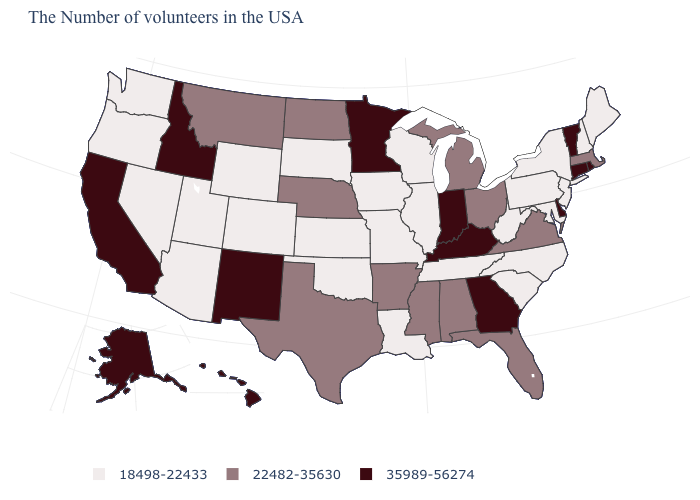Which states have the lowest value in the Northeast?
Answer briefly. Maine, New Hampshire, New York, New Jersey, Pennsylvania. Is the legend a continuous bar?
Keep it brief. No. Which states have the lowest value in the MidWest?
Concise answer only. Wisconsin, Illinois, Missouri, Iowa, Kansas, South Dakota. What is the value of Alabama?
Write a very short answer. 22482-35630. Name the states that have a value in the range 22482-35630?
Give a very brief answer. Massachusetts, Virginia, Ohio, Florida, Michigan, Alabama, Mississippi, Arkansas, Nebraska, Texas, North Dakota, Montana. What is the lowest value in states that border Iowa?
Keep it brief. 18498-22433. Name the states that have a value in the range 22482-35630?
Answer briefly. Massachusetts, Virginia, Ohio, Florida, Michigan, Alabama, Mississippi, Arkansas, Nebraska, Texas, North Dakota, Montana. Name the states that have a value in the range 18498-22433?
Keep it brief. Maine, New Hampshire, New York, New Jersey, Maryland, Pennsylvania, North Carolina, South Carolina, West Virginia, Tennessee, Wisconsin, Illinois, Louisiana, Missouri, Iowa, Kansas, Oklahoma, South Dakota, Wyoming, Colorado, Utah, Arizona, Nevada, Washington, Oregon. What is the value of Washington?
Concise answer only. 18498-22433. How many symbols are there in the legend?
Answer briefly. 3. Name the states that have a value in the range 35989-56274?
Keep it brief. Rhode Island, Vermont, Connecticut, Delaware, Georgia, Kentucky, Indiana, Minnesota, New Mexico, Idaho, California, Alaska, Hawaii. How many symbols are there in the legend?
Keep it brief. 3. What is the highest value in the USA?
Short answer required. 35989-56274. Name the states that have a value in the range 35989-56274?
Keep it brief. Rhode Island, Vermont, Connecticut, Delaware, Georgia, Kentucky, Indiana, Minnesota, New Mexico, Idaho, California, Alaska, Hawaii. 